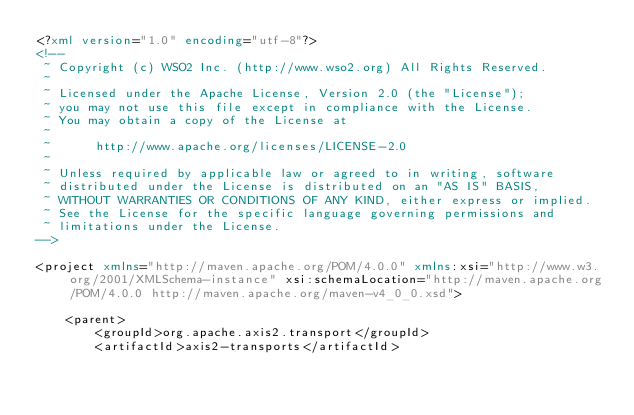Convert code to text. <code><loc_0><loc_0><loc_500><loc_500><_XML_><?xml version="1.0" encoding="utf-8"?>
<!--
 ~ Copyright (c) WSO2 Inc. (http://www.wso2.org) All Rights Reserved.
 ~
 ~ Licensed under the Apache License, Version 2.0 (the "License");
 ~ you may not use this file except in compliance with the License.
 ~ You may obtain a copy of the License at
 ~
 ~      http://www.apache.org/licenses/LICENSE-2.0
 ~
 ~ Unless required by applicable law or agreed to in writing, software
 ~ distributed under the License is distributed on an "AS IS" BASIS,
 ~ WITHOUT WARRANTIES OR CONDITIONS OF ANY KIND, either express or implied.
 ~ See the License for the specific language governing permissions and
 ~ limitations under the License.
-->

<project xmlns="http://maven.apache.org/POM/4.0.0" xmlns:xsi="http://www.w3.org/2001/XMLSchema-instance" xsi:schemaLocation="http://maven.apache.org/POM/4.0.0 http://maven.apache.org/maven-v4_0_0.xsd">

    <parent>
        <groupId>org.apache.axis2.transport</groupId>
        <artifactId>axis2-transports</artifactId></code> 